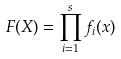<formula> <loc_0><loc_0><loc_500><loc_500>F ( X ) = \prod _ { i = 1 } ^ { s } f _ { i } ( x )</formula> 